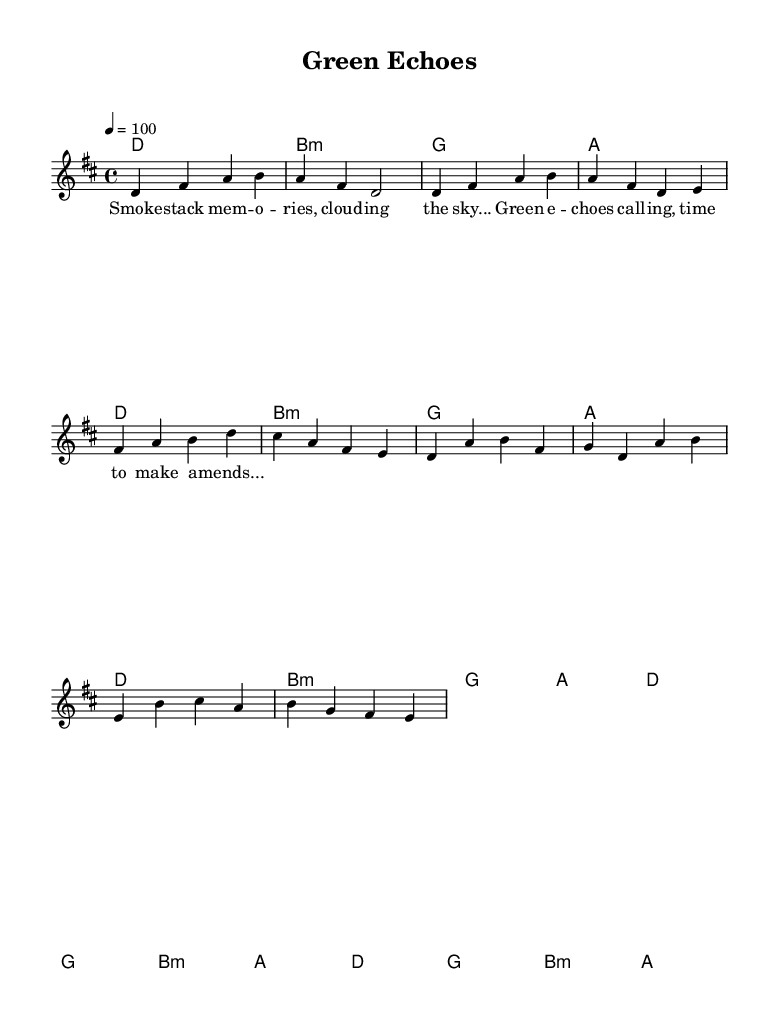What is the key signature of this music? The key signature is D major, which contains two sharps: F# and C#. This can be confirmed by examining the key signature indicated at the beginning of the score.
Answer: D major What is the time signature of this music? The time signature is 4/4, which indicates that there are four beats in each measure and the quarter note receives one beat. This can be found at the beginning of the piece, right after the key signature.
Answer: 4/4 What is the tempo marking of this piece? The tempo marking is 100, which is specified as a dotted quarter note equals 100. This is mentioned in the tempo directive at the beginning of the score.
Answer: 100 How many measures are in the verse section? The verse section contains 4 measures. This can be counted by looking at the melody notes and harmonies written for the verse section.
Answer: 4 Which chord starts the chorus section? The chorus section starts with the D major chord. This can be identified by looking at the first chord indicated in the chorus portion of the score.
Answer: D What theme does the lyrics of this song explore? The lyrics explore themes of ecological redemption and personal responsibility, emphasized by phrases about making amends for past environmental impacts. This is inferred from the provided lyrics in the verse and chorus sections.
Answer: Ecological redemption What type of musical work is this? This musical work is a famous song. This classification comes from the context given about its contemporary indie rock style that explores significant themes.
Answer: Famous song 